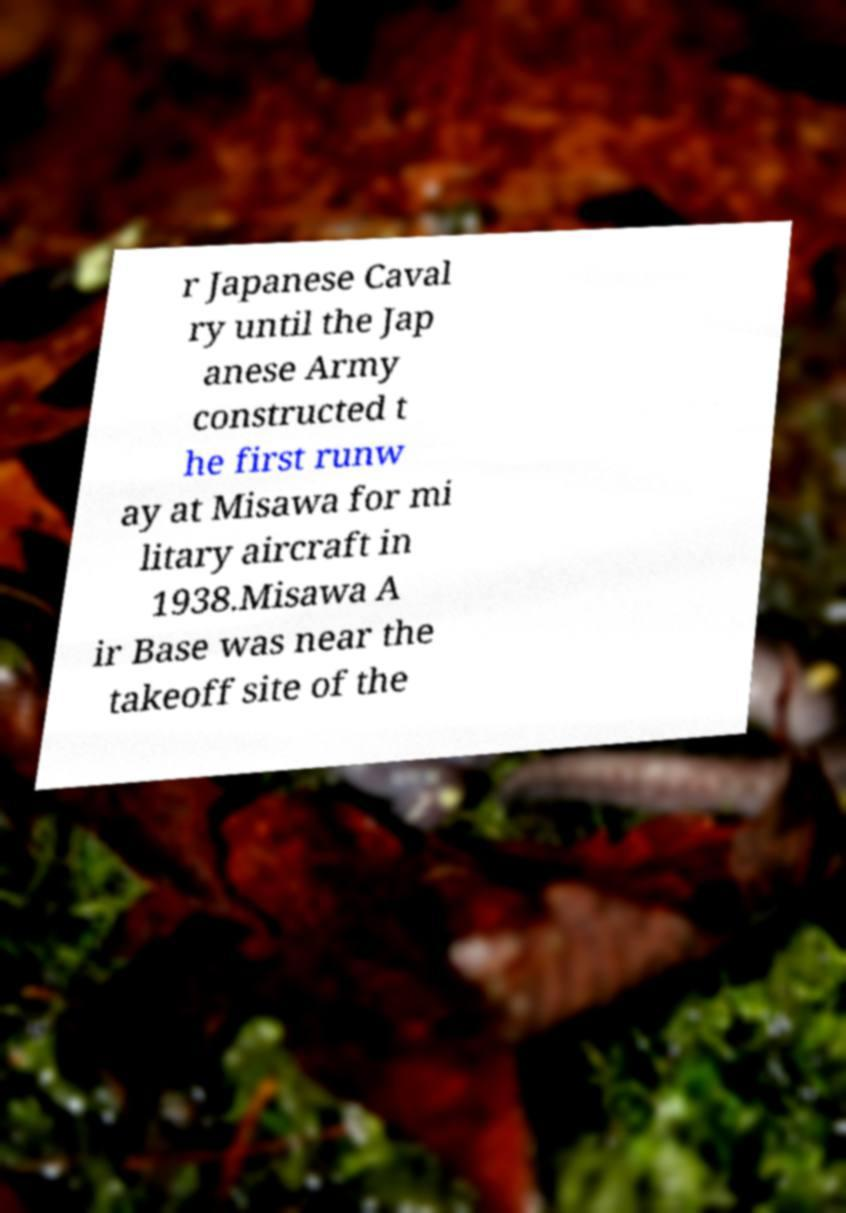Could you extract and type out the text from this image? r Japanese Caval ry until the Jap anese Army constructed t he first runw ay at Misawa for mi litary aircraft in 1938.Misawa A ir Base was near the takeoff site of the 